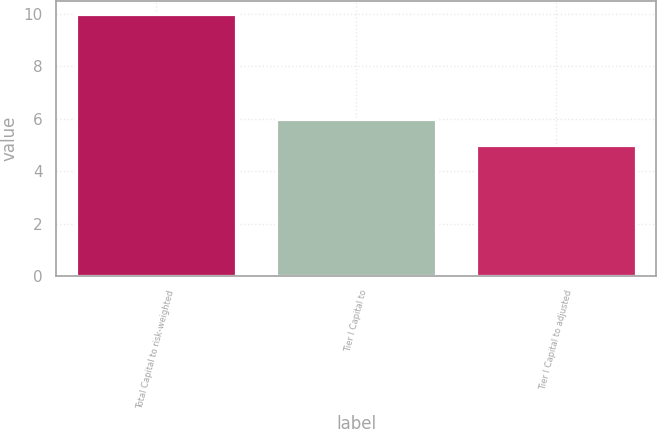Convert chart to OTSL. <chart><loc_0><loc_0><loc_500><loc_500><bar_chart><fcel>Total Capital to risk-weighted<fcel>Tier I Capital to<fcel>Tier I Capital to adjusted<nl><fcel>10<fcel>6<fcel>5<nl></chart> 